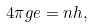Convert formula to latex. <formula><loc_0><loc_0><loc_500><loc_500>4 \pi g e = n h ,</formula> 